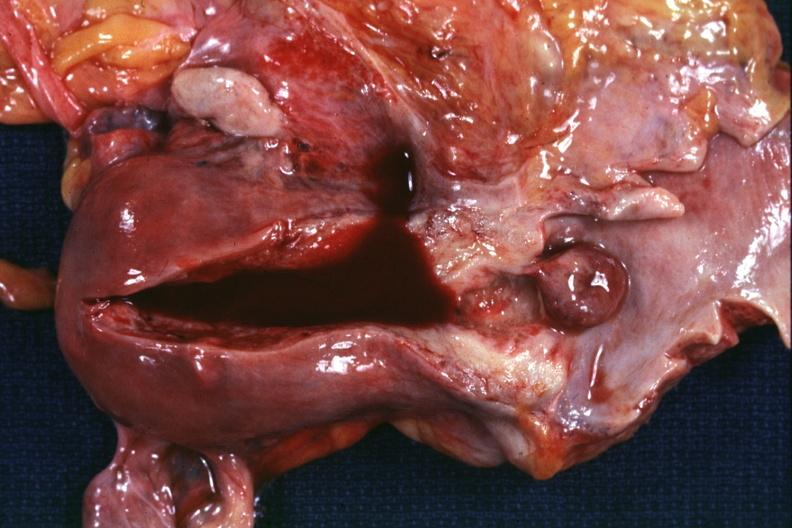what does this image show?
Answer the question using a single word or phrase. Opened uterus and vagina with pedunculated polyp extending from cervix into vagina 72yobf 